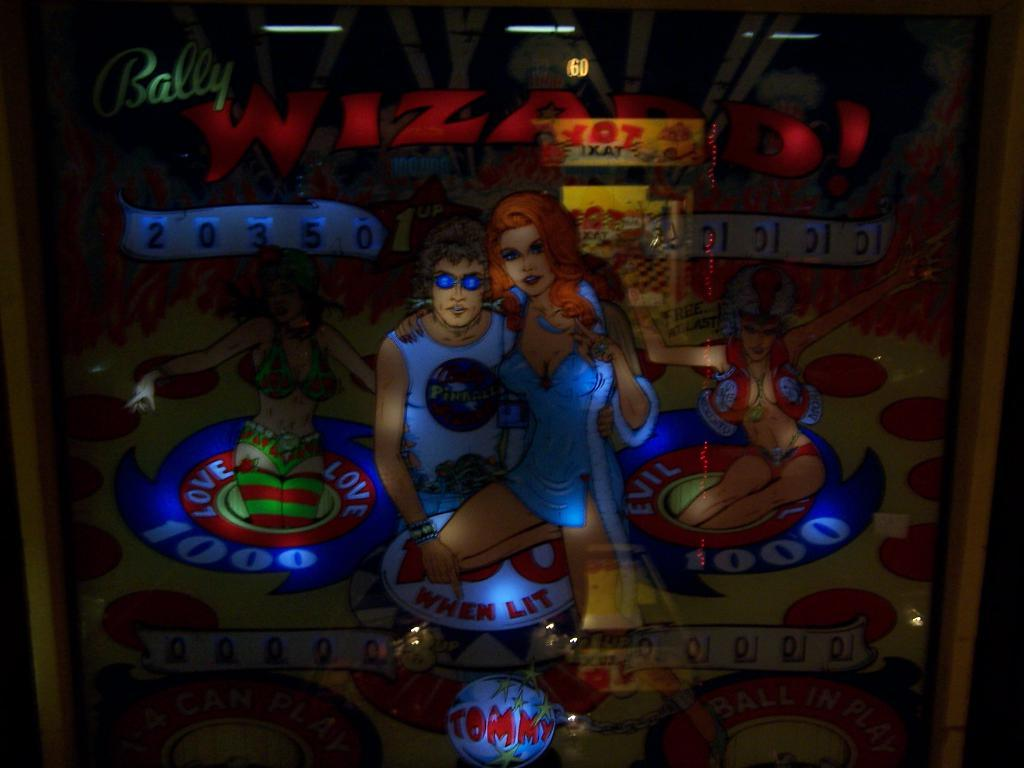<image>
Share a concise interpretation of the image provided. A score screen for the pinball game Wizard by Bally. 